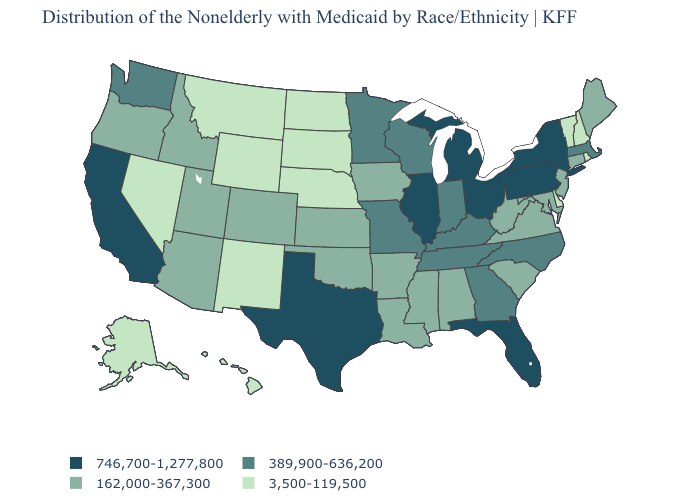Name the states that have a value in the range 746,700-1,277,800?
Be succinct. California, Florida, Illinois, Michigan, New York, Ohio, Pennsylvania, Texas. Name the states that have a value in the range 746,700-1,277,800?
Concise answer only. California, Florida, Illinois, Michigan, New York, Ohio, Pennsylvania, Texas. What is the lowest value in the USA?
Keep it brief. 3,500-119,500. Which states have the lowest value in the Northeast?
Short answer required. New Hampshire, Rhode Island, Vermont. Name the states that have a value in the range 3,500-119,500?
Keep it brief. Alaska, Delaware, Hawaii, Montana, Nebraska, Nevada, New Hampshire, New Mexico, North Dakota, Rhode Island, South Dakota, Vermont, Wyoming. Name the states that have a value in the range 162,000-367,300?
Answer briefly. Alabama, Arizona, Arkansas, Colorado, Connecticut, Idaho, Iowa, Kansas, Louisiana, Maine, Maryland, Mississippi, New Jersey, Oklahoma, Oregon, South Carolina, Utah, Virginia, West Virginia. What is the value of Louisiana?
Quick response, please. 162,000-367,300. What is the value of Tennessee?
Quick response, please. 389,900-636,200. Which states have the lowest value in the South?
Write a very short answer. Delaware. What is the value of New Jersey?
Concise answer only. 162,000-367,300. Which states have the lowest value in the South?
Short answer required. Delaware. Name the states that have a value in the range 3,500-119,500?
Concise answer only. Alaska, Delaware, Hawaii, Montana, Nebraska, Nevada, New Hampshire, New Mexico, North Dakota, Rhode Island, South Dakota, Vermont, Wyoming. What is the highest value in the USA?
Give a very brief answer. 746,700-1,277,800. What is the value of Pennsylvania?
Write a very short answer. 746,700-1,277,800. 